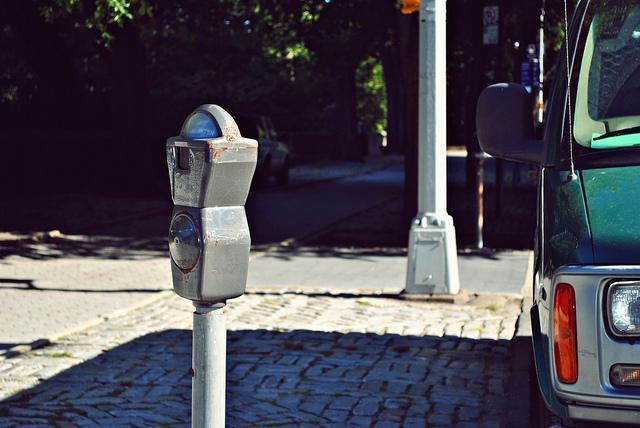How many parking meters are visible?
Give a very brief answer. 2. How many cars can you see?
Give a very brief answer. 2. 